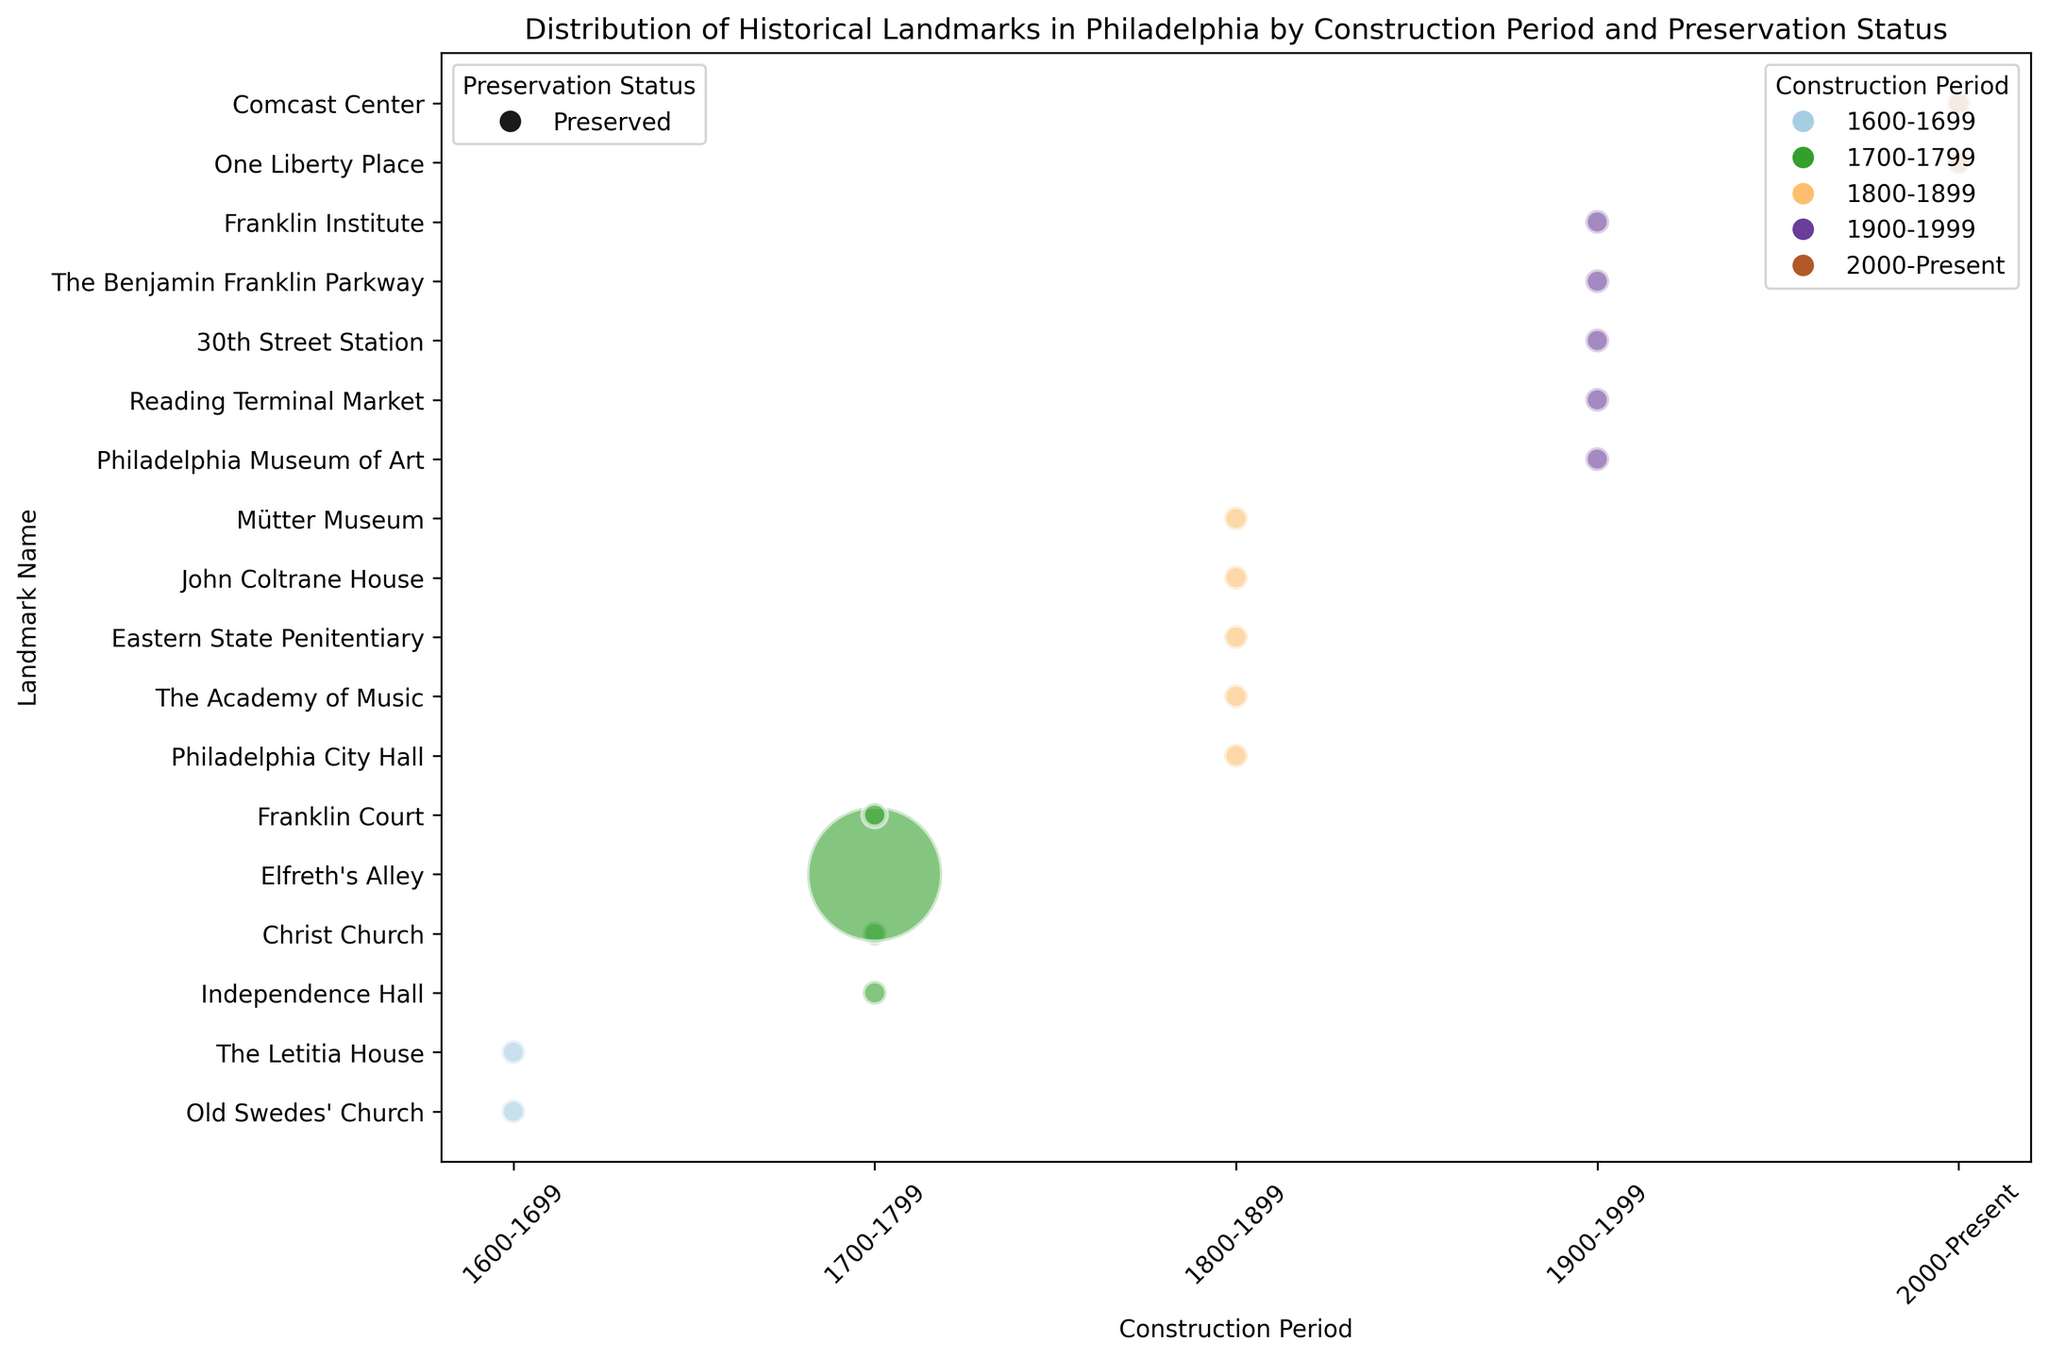Which construction period has the most landmarks preserved? To find this, look at the colors corresponding to each period on the x-axis and count the bubbles. The 1700-1799 period has the most bubbles, indicating the most preserved landmarks.
Answer: 1700-1799 Which landmark is represented by the largest bubble? The size of the bubble correlates with the number of sites. Elfreth's Alley, in the 1700-1799 period, has the largest bubble, indicating it has the most sites (32).
Answer: Elfreth's Alley How many landmarks were constructed during the 1800-1899 period? Look at the color representing the 1800-1899 period and count all the bubbles within that range on the x-axis. There are five landmarks.
Answer: 5 Which construction period has landmarks with different preservation statuses? Checking the bubbles and their labels, all landmarks fall into one preservation status, "Preserved."
Answer: None Among 1700-1799 and 1800-1899 periods, which one has a smaller total number of sites? The 1700-1799 period has 36 sites in total (32 from Elfreth's Alley and 1 each from the other landmarks). The 1800-1899 period has 5 sites. Thus, the 1800-1899 period has fewer preserved sites.
Answer: 1800-1899 Which landmark from the 1900-1999 period is preserved? Look at the bubbles tagged "1900-1999" on the x-axis to find out which landmarks fall in this period. The landmarks are Philadelphia Museum of Art, Reading Terminal Market, 30th Street Station, The Benjamin Franklin Parkway, and Franklin Institute. All of them share the same preservation status ("Preserved").
Answer: Philadelphia Museum of Art (and others) Is there any landmark from the 1600-1699 period? Check if any bubbles are placed within the x-axis range labeled "1600-1699". There are two bubbles: Old Swedes' Church and The Letitia House.
Answer: Yes How many periods have only one landmark? Look at each period on the x-axis and count the unique bubbles. The periods "1600-1699" and "1700-1799" each have multiple landmarks, but "2000-Present" has only one.
Answer: 1 